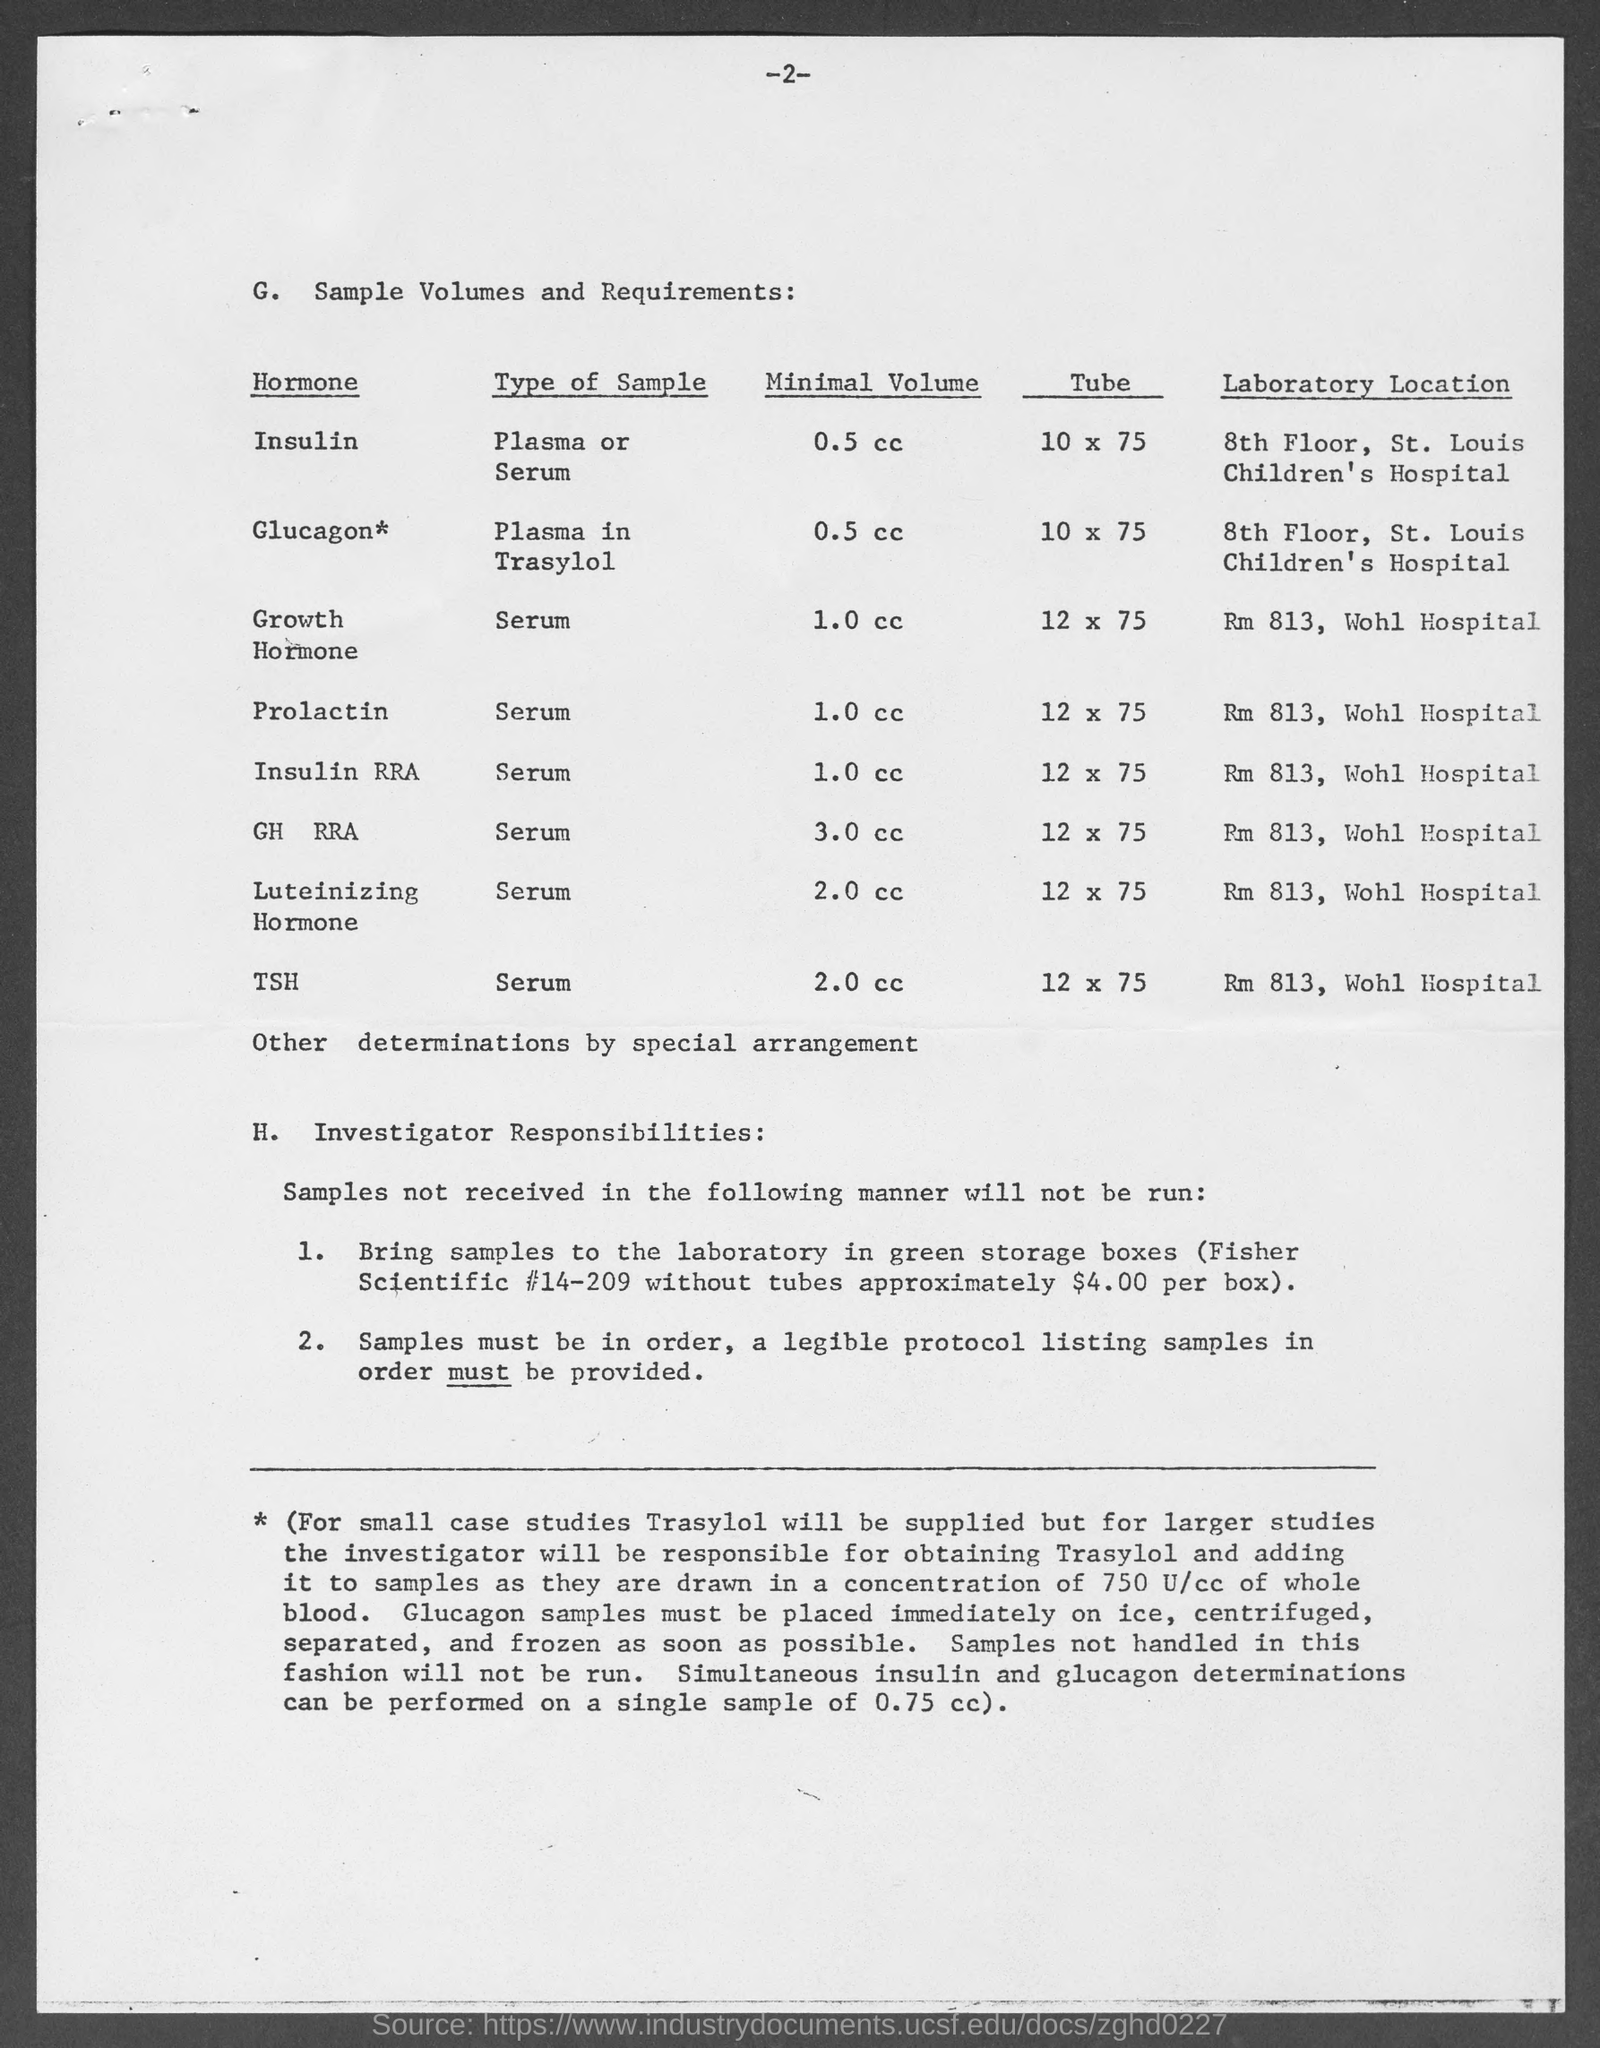What is the minimal volume for Insulin?
Ensure brevity in your answer.  0.5 cc. What is the minimal volume for Glucagon?
Offer a terse response. 0.5 cc. What is the minimal volume for Growth hormone?
Your answer should be very brief. 1.0 cc. What is the minimal volume for Prolactin?
Keep it short and to the point. 1.0 cc. What is the minimal volume for Insulin RRA?
Your answer should be very brief. 1.0 cc. What is the minimal volume for GH RRA?
Your answer should be very brief. 3.0 cc. What is the minimal volume for Luteinizing Hormone?
Ensure brevity in your answer.  2.0 cc. What is the minimal volume for TSH?
Ensure brevity in your answer.  2.0 cc. What is the Type of sample  for Prolactin?
Keep it short and to the point. Serum. What is the Type of sample for Insulin RRA?
Ensure brevity in your answer.  Serum. 